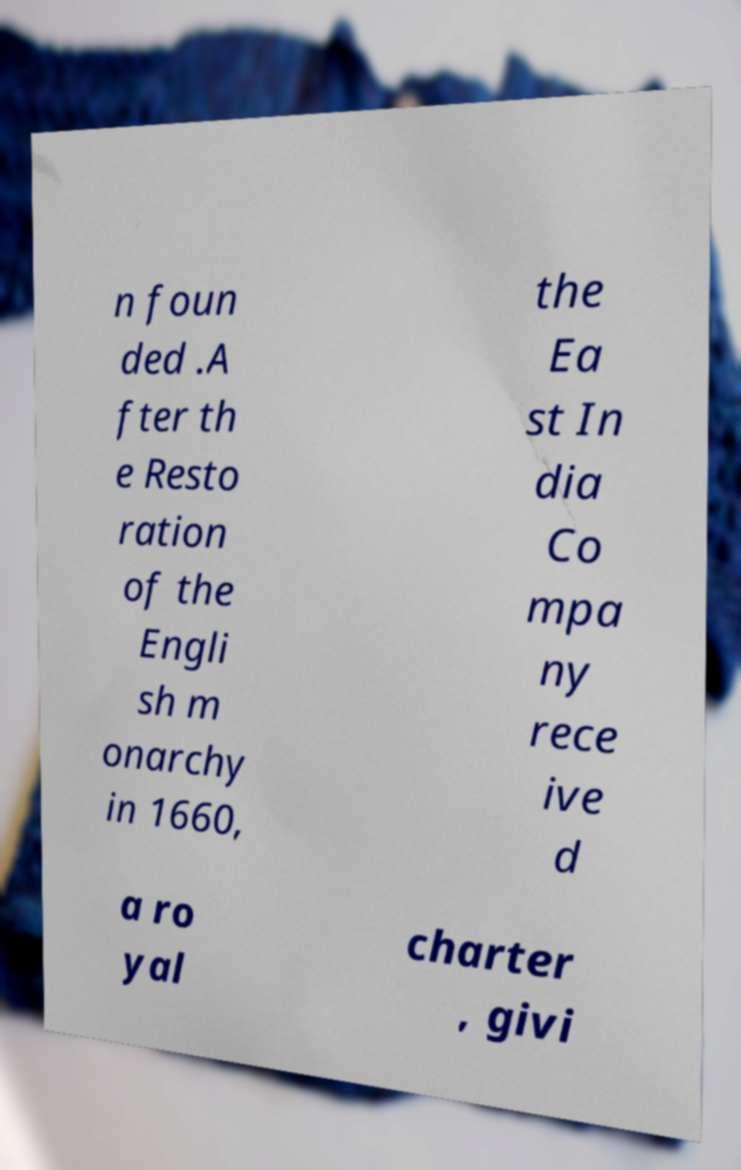What messages or text are displayed in this image? I need them in a readable, typed format. n foun ded .A fter th e Resto ration of the Engli sh m onarchy in 1660, the Ea st In dia Co mpa ny rece ive d a ro yal charter , givi 